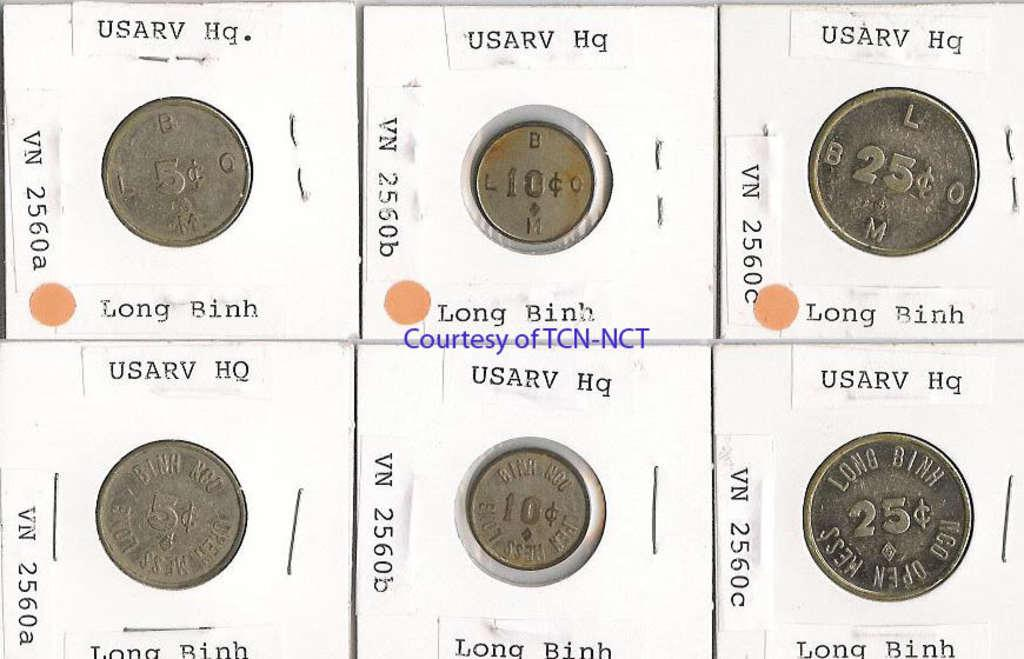Provide a one-sentence caption for the provided image. Six coins are packaged and the middle of the grouping says courtesy of TCN NCT. 